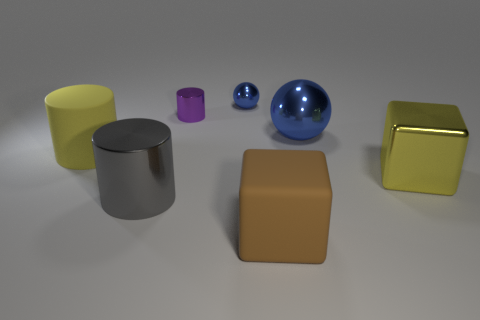There is a tiny metal thing that is on the right side of the purple cylinder; what is its color?
Give a very brief answer. Blue. There is a thing that is the same color as the tiny shiny sphere; what shape is it?
Make the answer very short. Sphere. The thing behind the small purple metallic object has what shape?
Provide a short and direct response. Sphere. How many yellow things are either cubes or large metallic spheres?
Provide a short and direct response. 1. Do the large brown object and the small purple cylinder have the same material?
Provide a succinct answer. No. How many tiny blue shiny balls are left of the gray object?
Make the answer very short. 0. The thing that is both in front of the metal block and left of the purple thing is made of what material?
Give a very brief answer. Metal. What number of spheres are tiny blue metallic objects or shiny objects?
Ensure brevity in your answer.  2. There is a yellow object that is the same shape as the purple metal thing; what is it made of?
Your answer should be very brief. Rubber. What size is the cube that is made of the same material as the tiny ball?
Provide a succinct answer. Large. 